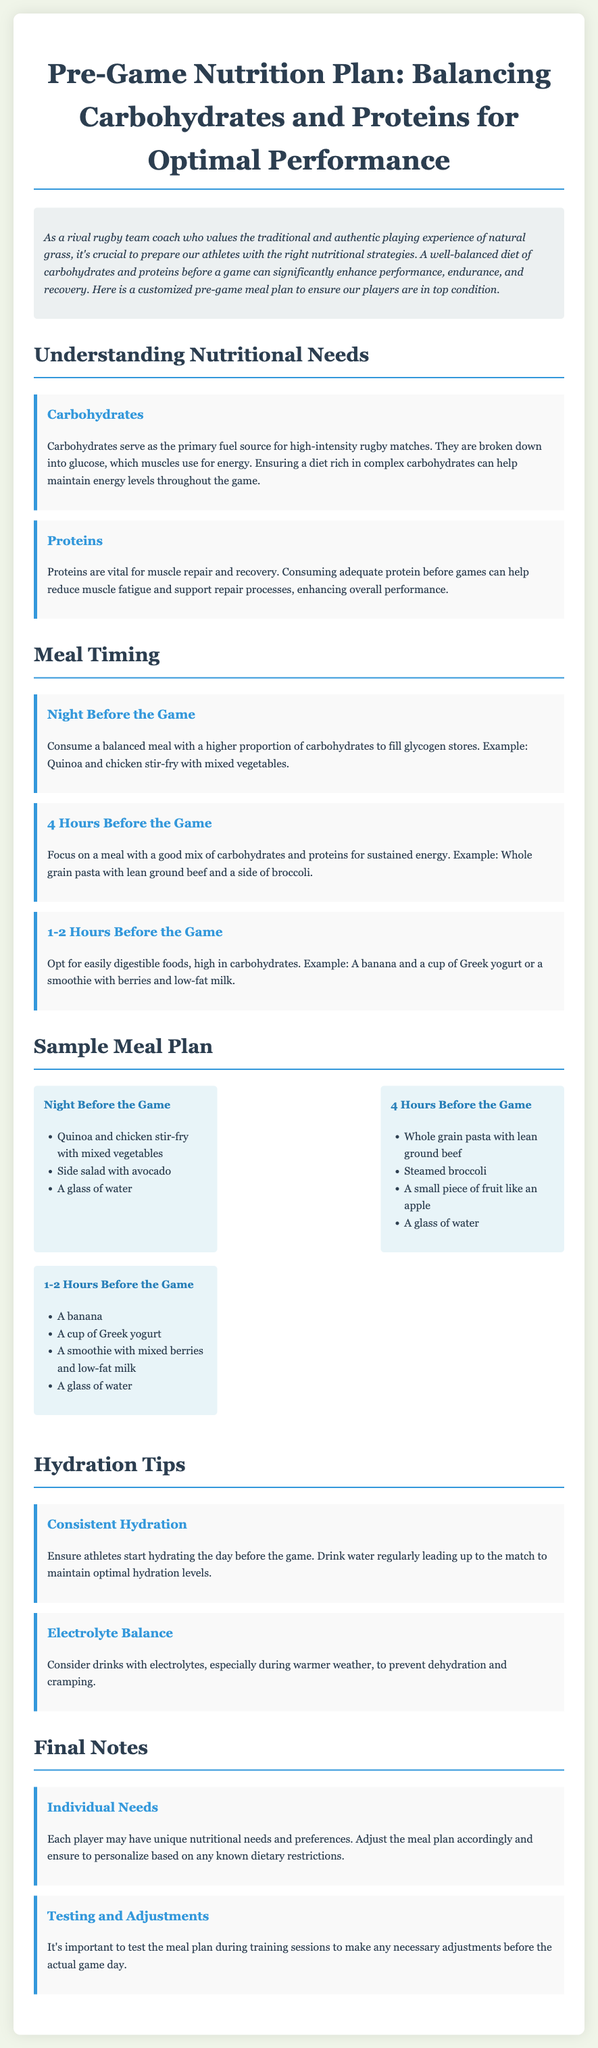What is the title of the document? The title is centered at the top of the document and clearly stated.
Answer: Pre-Game Nutrition Plan: Balancing Carbohydrates and Proteins for Optimal Performance What is the meal recommended the night before the game? The document lists specific meals for different times before the game.
Answer: Quinoa and chicken stir-fry with mixed vegetables How many hours before the game should one eat whole grain pasta? This information is crucial for timing the meals appropriately.
Answer: 4 Hours Before the Game What type of hydration tips are provided? The document includes a section specifically addressing hydration needs.
Answer: Consistent Hydration How can proteins benefit athletes before games? The explanation given in the document summarizes a key reason for protein intake.
Answer: Muscle repair and recovery What type of fruit is suggested 1-2 hours before the game? This detail focuses on quick energy sources.
Answer: A banana What should players consider in adjusting meal plans? This reflects an important aspect of personalized nutrition for athletes.
Answer: Individual Needs Which component of nutrition serves as the primary fuel source? This is clearly stated when discussing nutritional needs.
Answer: Carbohydrates What is mentioned about electrolyte drinks? The document gives specific advice for hydration in certain conditions.
Answer: Prevent dehydration and cramping 